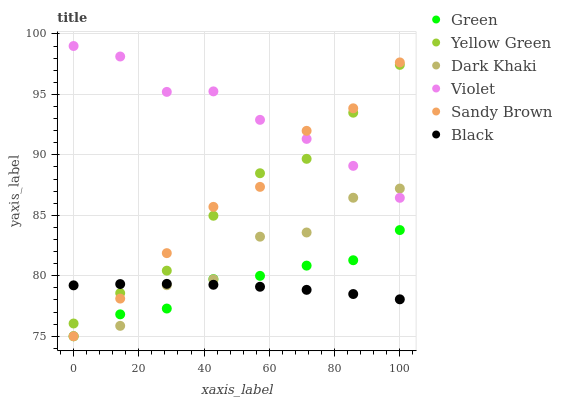Does Black have the minimum area under the curve?
Answer yes or no. Yes. Does Violet have the maximum area under the curve?
Answer yes or no. Yes. Does Dark Khaki have the minimum area under the curve?
Answer yes or no. No. Does Dark Khaki have the maximum area under the curve?
Answer yes or no. No. Is Black the smoothest?
Answer yes or no. Yes. Is Dark Khaki the roughest?
Answer yes or no. Yes. Is Green the smoothest?
Answer yes or no. No. Is Green the roughest?
Answer yes or no. No. Does Dark Khaki have the lowest value?
Answer yes or no. Yes. Does Violet have the lowest value?
Answer yes or no. No. Does Violet have the highest value?
Answer yes or no. Yes. Does Dark Khaki have the highest value?
Answer yes or no. No. Is Green less than Violet?
Answer yes or no. Yes. Is Violet greater than Black?
Answer yes or no. Yes. Does Dark Khaki intersect Green?
Answer yes or no. Yes. Is Dark Khaki less than Green?
Answer yes or no. No. Is Dark Khaki greater than Green?
Answer yes or no. No. Does Green intersect Violet?
Answer yes or no. No. 